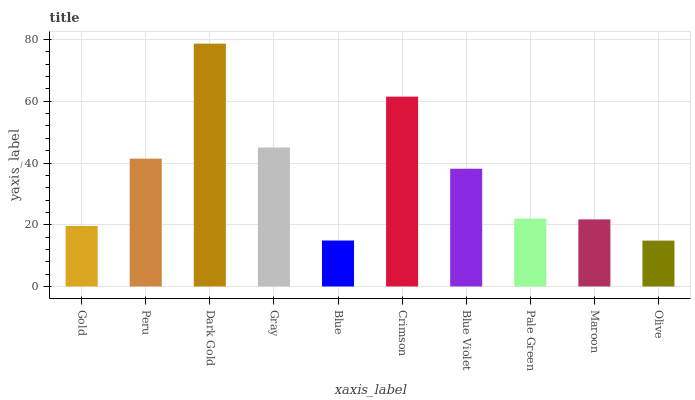Is Olive the minimum?
Answer yes or no. Yes. Is Dark Gold the maximum?
Answer yes or no. Yes. Is Peru the minimum?
Answer yes or no. No. Is Peru the maximum?
Answer yes or no. No. Is Peru greater than Gold?
Answer yes or no. Yes. Is Gold less than Peru?
Answer yes or no. Yes. Is Gold greater than Peru?
Answer yes or no. No. Is Peru less than Gold?
Answer yes or no. No. Is Blue Violet the high median?
Answer yes or no. Yes. Is Pale Green the low median?
Answer yes or no. Yes. Is Peru the high median?
Answer yes or no. No. Is Blue Violet the low median?
Answer yes or no. No. 